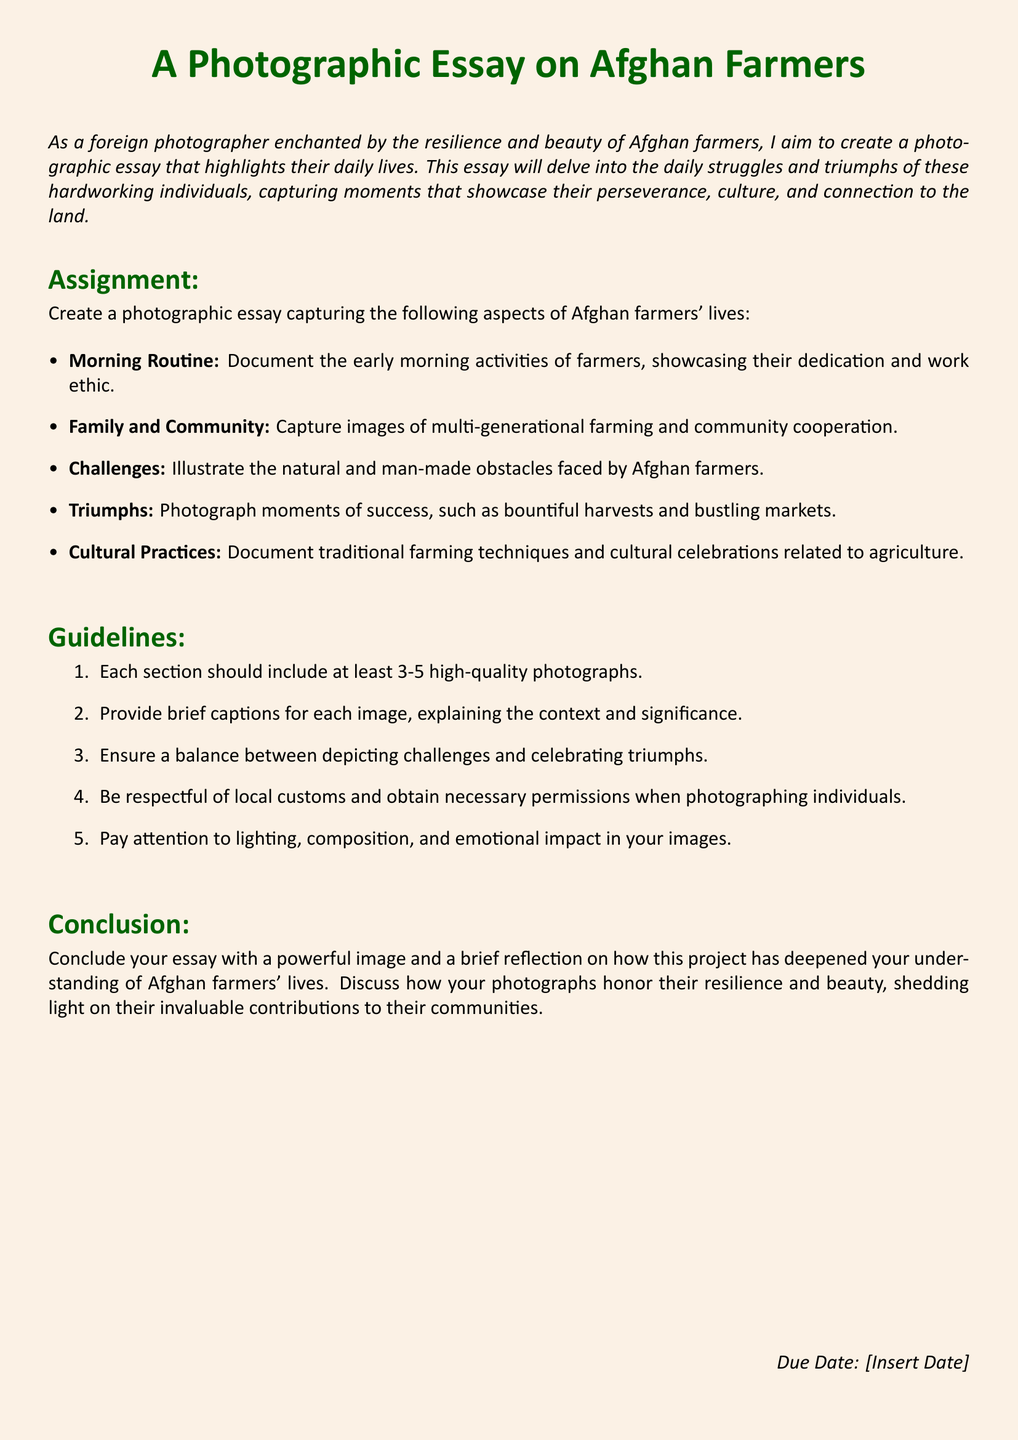What is the main subject of the photographic essay? The main subject of the photographic essay is the daily lives of Afghan farmers, including their struggles and triumphs.
Answer: Afghan farmers How many sections should the photographic essay include? The assignment details five distinct aspects to cover in the photographic essay.
Answer: Five What is one of the aspects of Afghan farmers' lives to document? The assignment outlines several aspects, including morning routines and community cooperation.
Answer: Morning Routine How many photographs are required in each section? Guidelines state that each section should include a specific number of high-quality photographs.
Answer: 3-5 What is a requirement when photographing individuals? The guidelines emphasize showing respect for local customs and obtaining necessary permissions.
Answer: Obtain permissions What should the conclusion of the essay include? The conclusion is meant to feature a powerful image and provide a reflection on the project.
Answer: A powerful image Why is capturing challenges important in this essay? The guidelines stress the need to balance the depiction of challenges with celebrating triumphs.
Answer: Balance of depiction What is the significance of cultural practices in the assignment? The assignment instructs documenting traditional farming techniques and cultural celebrations related to agriculture.
Answer: Traditional farming techniques 